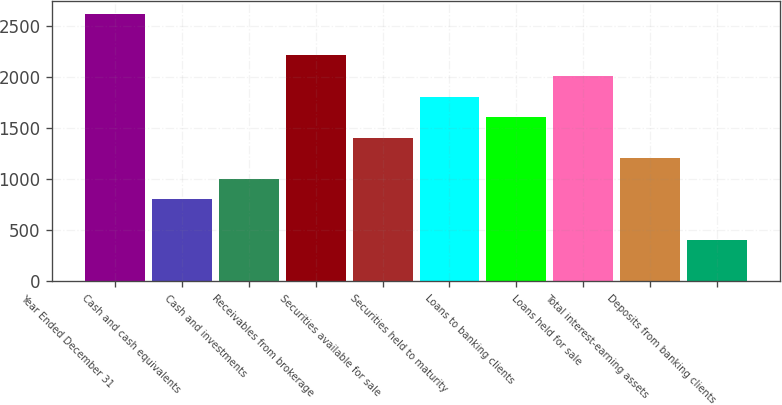<chart> <loc_0><loc_0><loc_500><loc_500><bar_chart><fcel>Year Ended December 31<fcel>Cash and cash equivalents<fcel>Cash and investments<fcel>Receivables from brokerage<fcel>Securities available for sale<fcel>Securities held to maturity<fcel>Loans to banking clients<fcel>Loans held for sale<fcel>Total interest-earning assets<fcel>Deposits from banking clients<nl><fcel>2611.72<fcel>803.62<fcel>1004.52<fcel>2209.92<fcel>1406.32<fcel>1808.12<fcel>1607.22<fcel>2009.02<fcel>1205.42<fcel>401.82<nl></chart> 